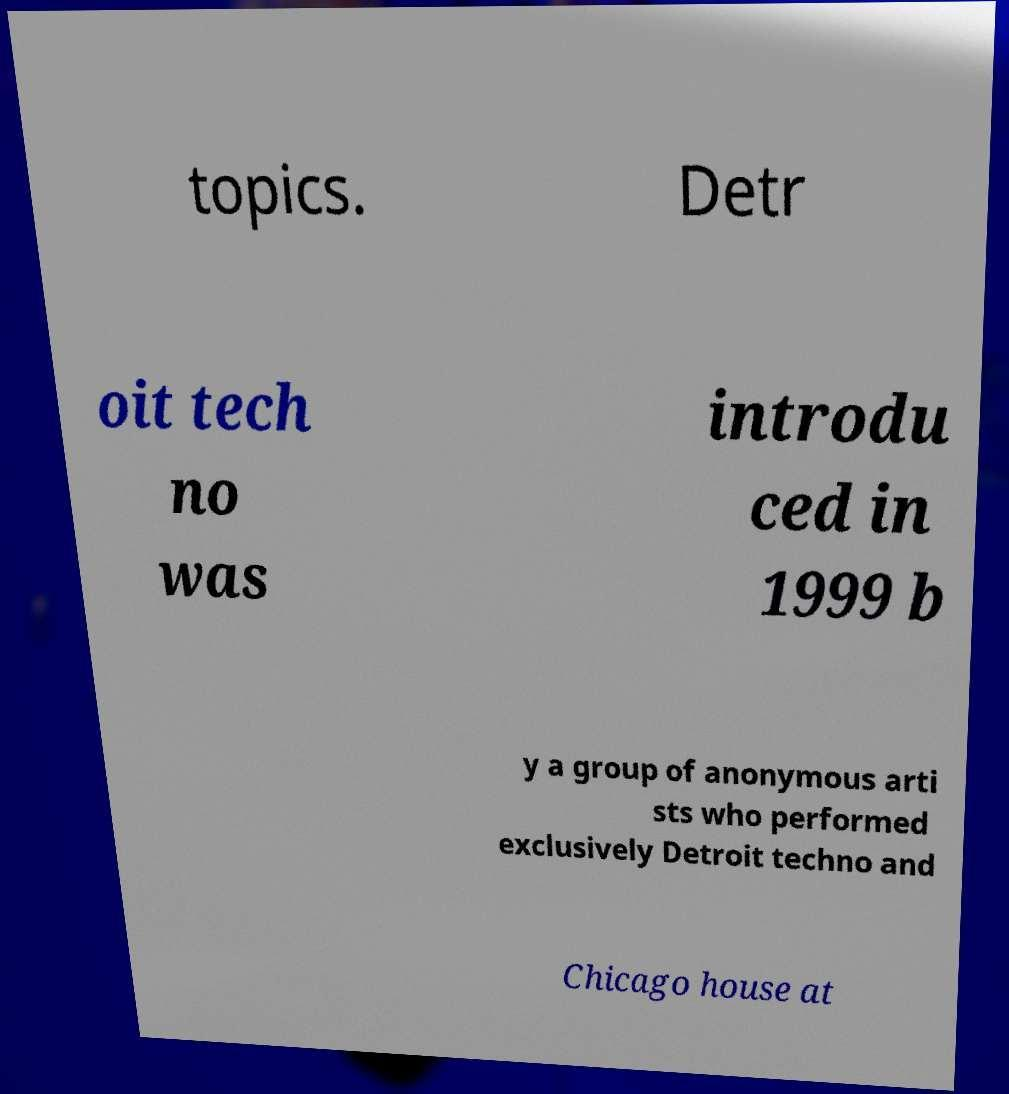What messages or text are displayed in this image? I need them in a readable, typed format. topics. Detr oit tech no was introdu ced in 1999 b y a group of anonymous arti sts who performed exclusively Detroit techno and Chicago house at 